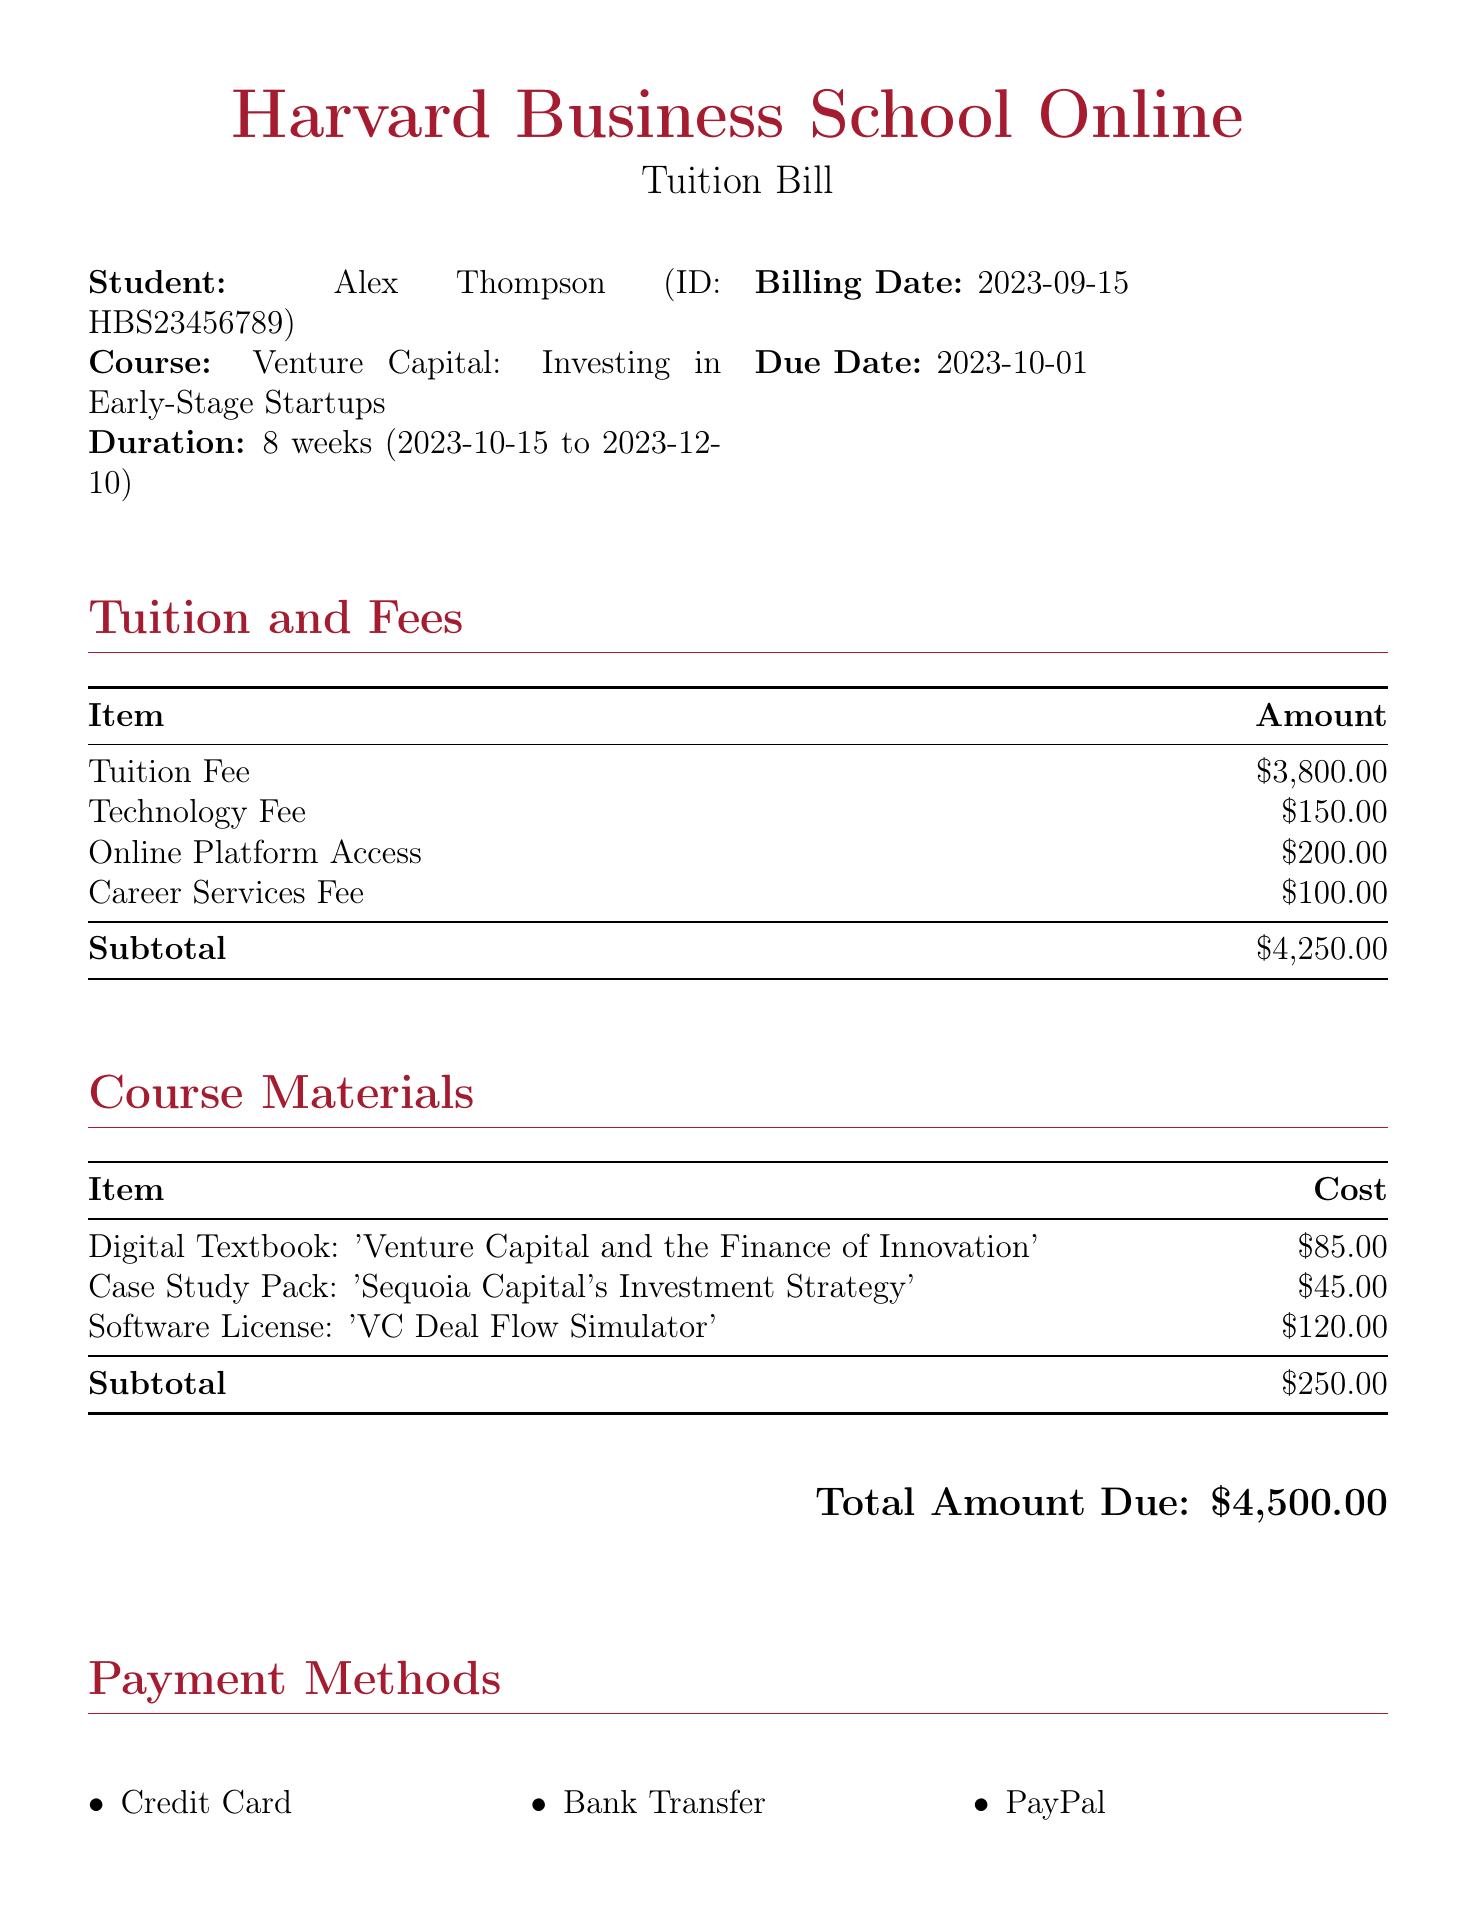what is the tuition fee? The tuition fee is listed under Tuition and Fees, specifically as $3,800.00.
Answer: $3,800.00 what is the total amount due? The total amount due is the sum of all fees and course materials, clearly stated at the bottom of the document.
Answer: $4,500.00 who is the student? The student’s name appears at the top of the document, identifying them as Alex Thompson.
Answer: Alex Thompson when is the due date for the payment? The due date is specified in the billing details section of the document as occurring on 2023-10-01.
Answer: 2023-10-01 how many weeks does the course last? The duration of the course is explicitly mentioned, indicating it lasts for 8 weeks.
Answer: 8 weeks what is the subtotal for course materials? The subtotal for course materials is provided in the breakdown section under Course Materials, which totals $250.00.
Answer: $250.00 what payment methods are available? The document states that there are three payment methods listed under Payment Methods: Credit Card, Bank Transfer, and PayPal.
Answer: Credit Card, Bank Transfer, PayPal what is the cost of the digital textbook? The cost of the digital textbook is specified in the Course Materials section as $85.00.
Answer: $85.00 what is the technology fee? The technology fee is detailed in the Tuition and Fees section, listed as $150.00.
Answer: $150.00 